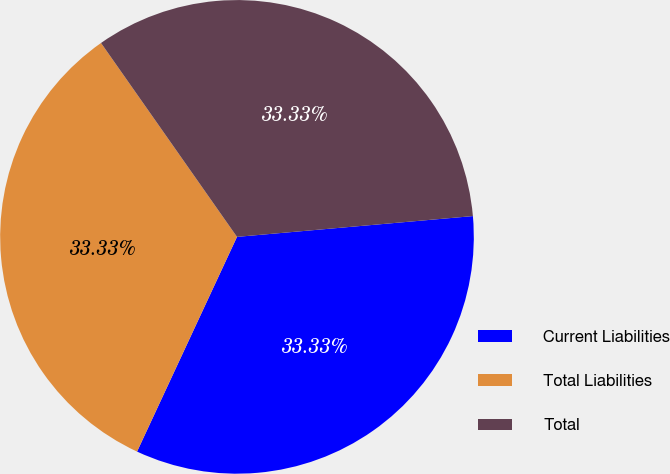Convert chart to OTSL. <chart><loc_0><loc_0><loc_500><loc_500><pie_chart><fcel>Current Liabilities<fcel>Total Liabilities<fcel>Total<nl><fcel>33.33%<fcel>33.33%<fcel>33.33%<nl></chart> 